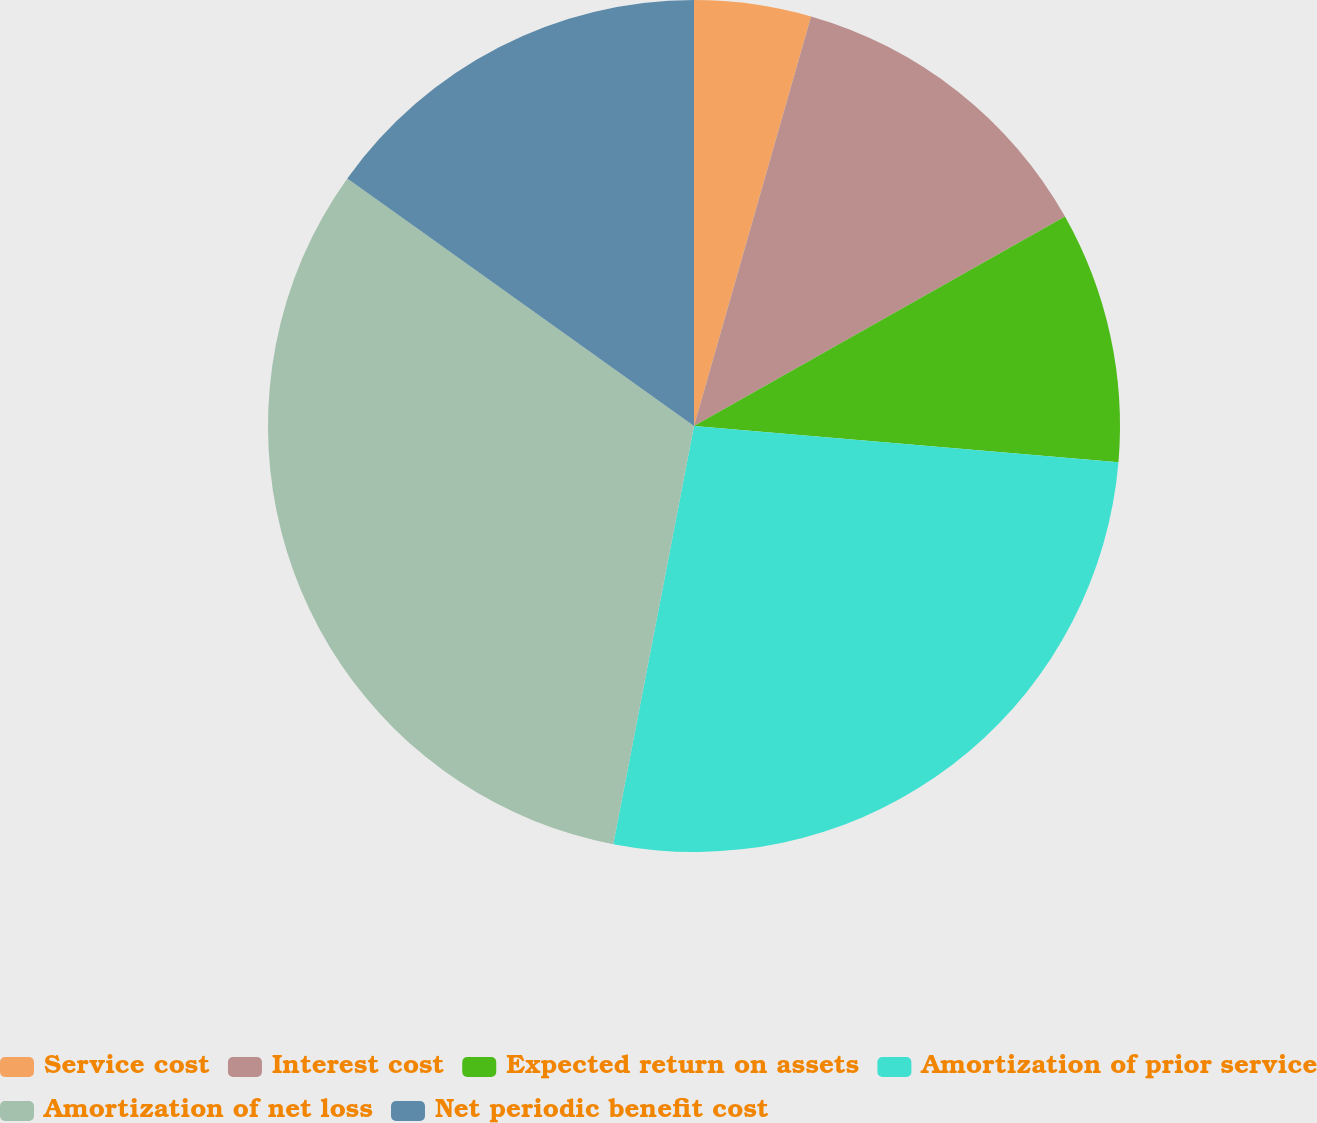Convert chart. <chart><loc_0><loc_0><loc_500><loc_500><pie_chart><fcel>Service cost<fcel>Interest cost<fcel>Expected return on assets<fcel>Amortization of prior service<fcel>Amortization of net loss<fcel>Net periodic benefit cost<nl><fcel>4.43%<fcel>12.39%<fcel>9.53%<fcel>26.68%<fcel>31.83%<fcel>15.13%<nl></chart> 